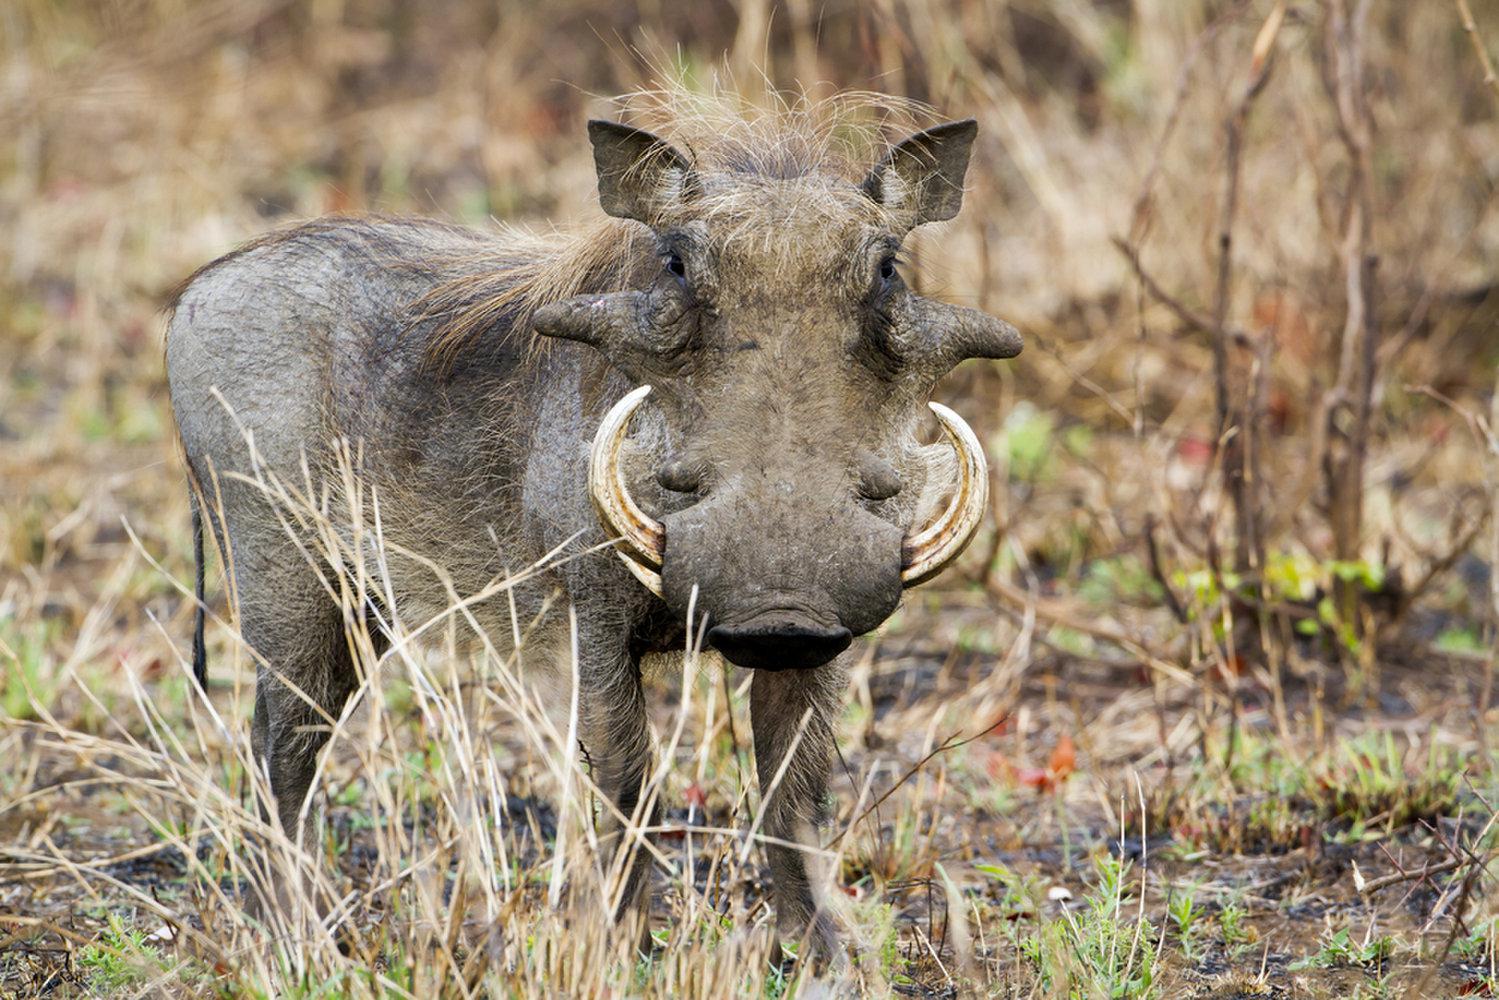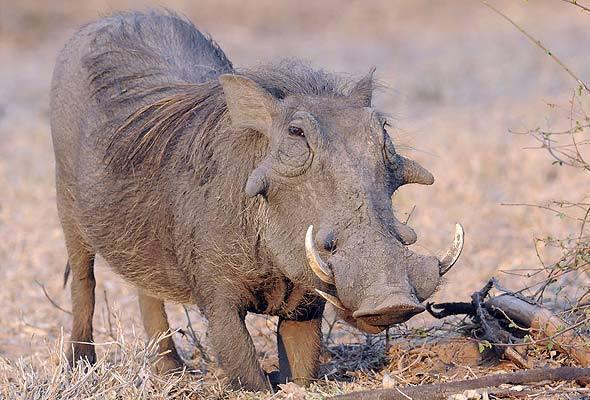The first image is the image on the left, the second image is the image on the right. Considering the images on both sides, is "There are two hogs, both facing the same direction." valid? Answer yes or no. Yes. The first image is the image on the left, the second image is the image on the right. Considering the images on both sides, is "Each image contains one warthog, and each warthog is standing with its body facing the same direction." valid? Answer yes or no. Yes. 